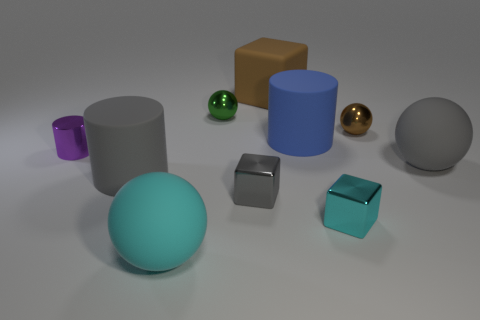Is the tiny green sphere made of the same material as the tiny purple cylinder?
Provide a short and direct response. Yes. How many things are either small metallic objects in front of the tiny brown metal object or gray matte cylinders?
Give a very brief answer. 4. What number of other objects are the same size as the blue rubber cylinder?
Your response must be concise. 4. Are there an equal number of large gray matte balls left of the matte cube and tiny metallic spheres that are in front of the cyan rubber thing?
Your response must be concise. Yes. What color is the other metal thing that is the same shape as the small gray shiny object?
Give a very brief answer. Cyan. Is the color of the small metallic ball on the right side of the big cube the same as the big rubber block?
Ensure brevity in your answer.  Yes. There is a matte object that is the same shape as the tiny cyan metal thing; what size is it?
Offer a terse response. Large. What number of tiny cyan objects have the same material as the big gray cylinder?
Offer a terse response. 0. There is a cylinder to the left of the rubber cylinder in front of the small purple object; is there a big cyan rubber sphere that is in front of it?
Keep it short and to the point. Yes. There is a large cyan matte object; what shape is it?
Make the answer very short. Sphere. 